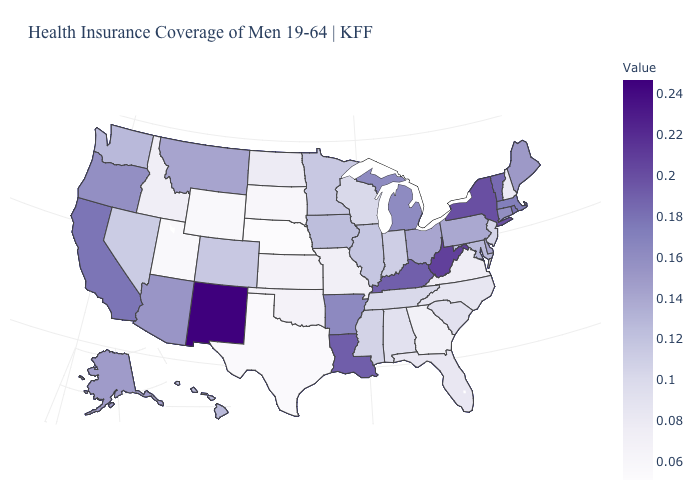Does Wisconsin have the lowest value in the MidWest?
Short answer required. No. Among the states that border New Jersey , which have the highest value?
Write a very short answer. New York. Which states have the lowest value in the USA?
Quick response, please. Nebraska. Does Nebraska have the lowest value in the USA?
Give a very brief answer. Yes. Which states hav the highest value in the MidWest?
Quick response, please. Michigan. Does Missouri have a higher value than Nebraska?
Keep it brief. Yes. 